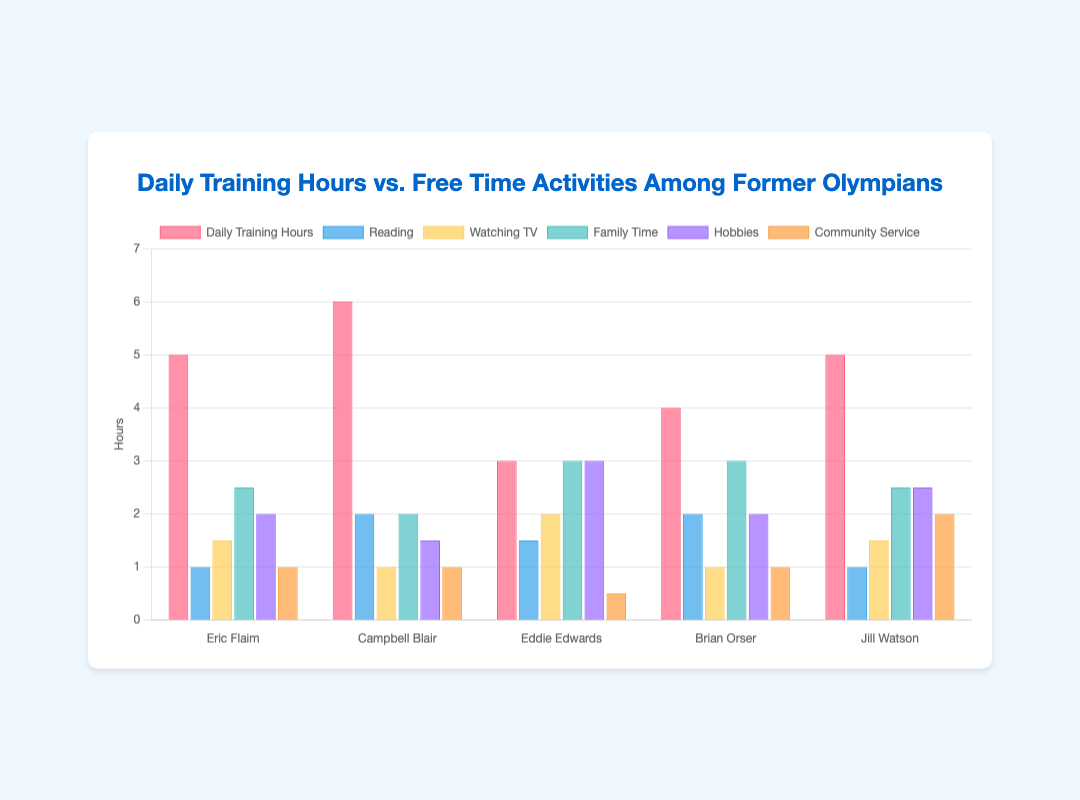Which former Olympian spends the most hours on daily training? Look for the highest value in the "Daily Training Hours" category. Campbell Blair trains the most with 6 hours.
Answer: Campbell Blair Which activity does Eddie Edwards spend the most time on? Identify the highest bar in Eddie Edwards' data. "Family Time" has the highest value of 3 hours.
Answer: Family Time What's the total amount of time Jill Watson spends on "Hobbies" and "Community Service"? Sum the values for Jill Watson in "Hobbies" and "Community Service." The values are 2.5 and 2, so 2.5 + 2 = 4.5 hours.
Answer: 4.5 Who spends equal hours on "Reading" and "Community Service"? Check if any values in "Reading" and "Community Service" are equal for the same person. Campbell Blair spends 1 hour on both.
Answer: Campbell Blair What is the average amount of daily training hours among all former Olympians? Sum the values in "Daily Training Hours" and divide by the number of Olympians: (5 + 6 + 3 + 4 + 5) / 5 = 4.6 hours.
Answer: 4.6 Compare the time Eric Flaim spends on "Watching TV" vs. "Family Time." Subtract the "Watching TV" time from the "Family Time" time for Eric Flaim: 2.5 - 1.5 = 1 hour.
Answer: 1 hour Which activity shows the least variation across all former Olympians? Identify the category where values are closest together. "Community Service" varies from 0.5 to 2, showing the smallest range.
Answer: Community Service How many hours does Brian Orser spend on "Daily Training Hours" compared to "Hobbies"? Compare the "Daily Training Hours" value with "Hobbies" for Brian Orser: 4 for training and 2 for hobbies. 4 - 2 = 2 more hours on training.
Answer: 2 more hours What is the most time-consuming activity for Campbell Blair? Identify the activity with the highest value for Campbell Blair. "Daily Training Hours" at 6 hours is the most time-consuming.
Answer: Daily Training Hours Compare the overall time spent on "Reading" by all former Olympians versus "Watching TV." Sum the values for both categories across all Olympians. Reading: 1 + 2 + 1.5 + 2 + 1 = 7.5 hours. Watching TV: 1.5 + 1 + 2 + 1 + 1.5 = 7 hours. Reading is higher by 0.5 hours.
Answer: Reading by 0.5 hours 